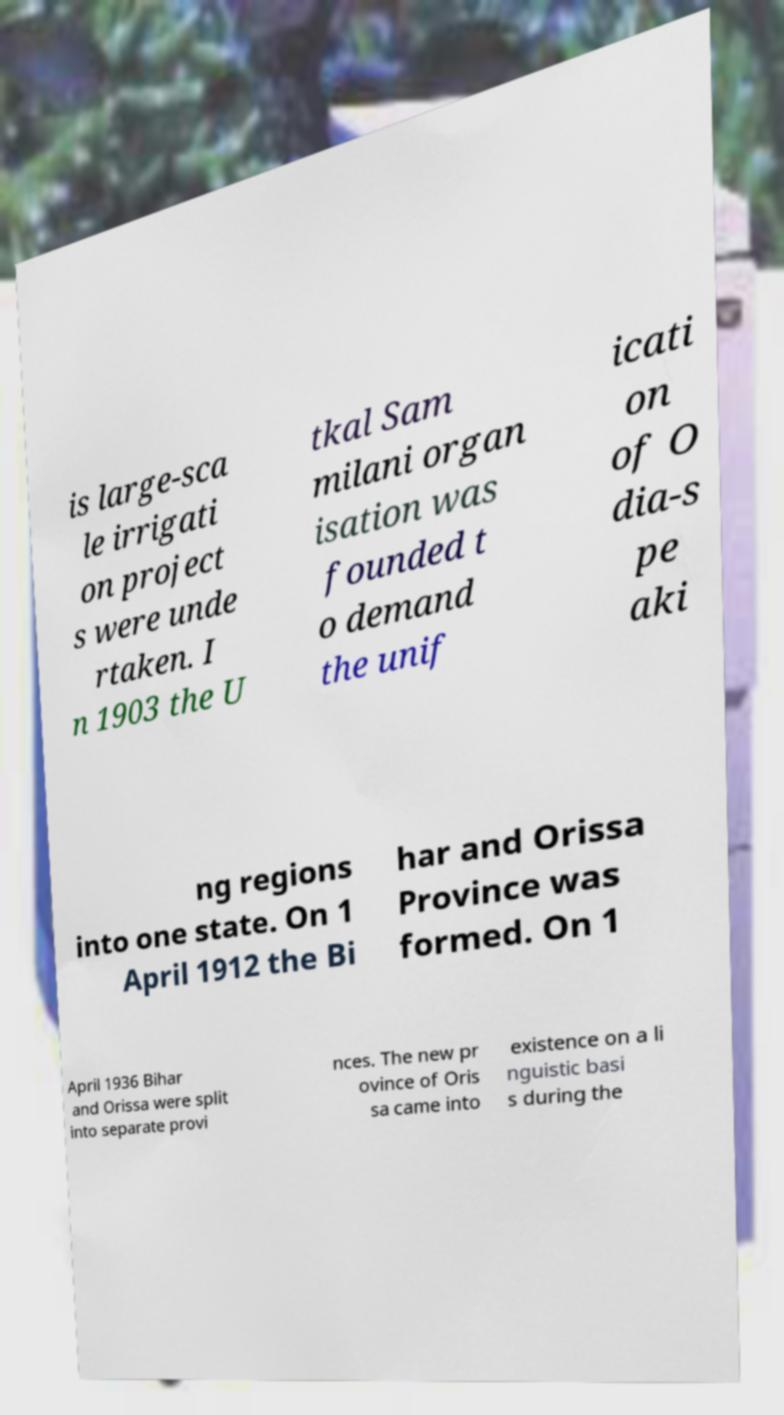Please read and relay the text visible in this image. What does it say? is large-sca le irrigati on project s were unde rtaken. I n 1903 the U tkal Sam milani organ isation was founded t o demand the unif icati on of O dia-s pe aki ng regions into one state. On 1 April 1912 the Bi har and Orissa Province was formed. On 1 April 1936 Bihar and Orissa were split into separate provi nces. The new pr ovince of Oris sa came into existence on a li nguistic basi s during the 